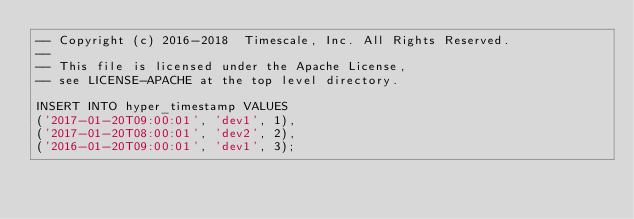Convert code to text. <code><loc_0><loc_0><loc_500><loc_500><_SQL_>-- Copyright (c) 2016-2018  Timescale, Inc. All Rights Reserved.
--
-- This file is licensed under the Apache License,
-- see LICENSE-APACHE at the top level directory.

INSERT INTO hyper_timestamp VALUES
('2017-01-20T09:00:01', 'dev1', 1),
('2017-01-20T08:00:01', 'dev2', 2),
('2016-01-20T09:00:01', 'dev1', 3);
</code> 